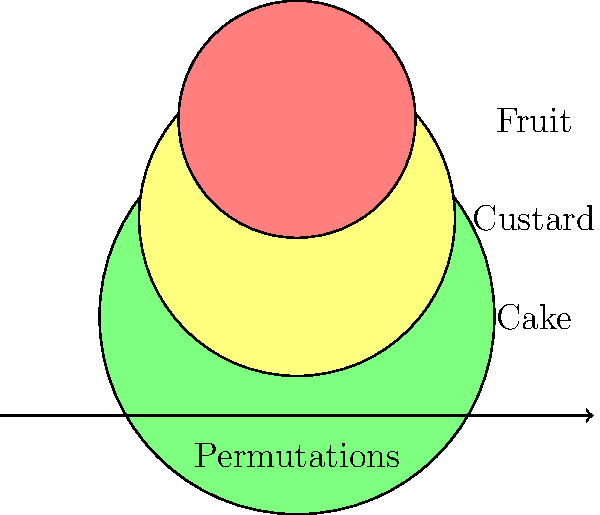You're planning to bake a layered dessert with three distinct layers: cake, custard, and fruit. How many different ways can you arrange these layers? Let's approach this step-by-step:

1. We have three distinct layers: cake, custard, and fruit.

2. This is a permutation problem, as we're arranging all three layers in different orders.

3. The number of permutations of $n$ distinct objects is given by $n!$ (n factorial).

4. In this case, $n = 3$ (three layers).

5. Therefore, the number of permutations is $3!$.

6. Calculate $3!$:
   $3! = 3 \times 2 \times 1 = 6$

So, there are 6 different ways to arrange the three layers.

These arrangements are:
1. Cake - Custard - Fruit
2. Cake - Fruit - Custard
3. Custard - Cake - Fruit
4. Custard - Fruit - Cake
5. Fruit - Cake - Custard
6. Fruit - Custard - Cake
Answer: 6 